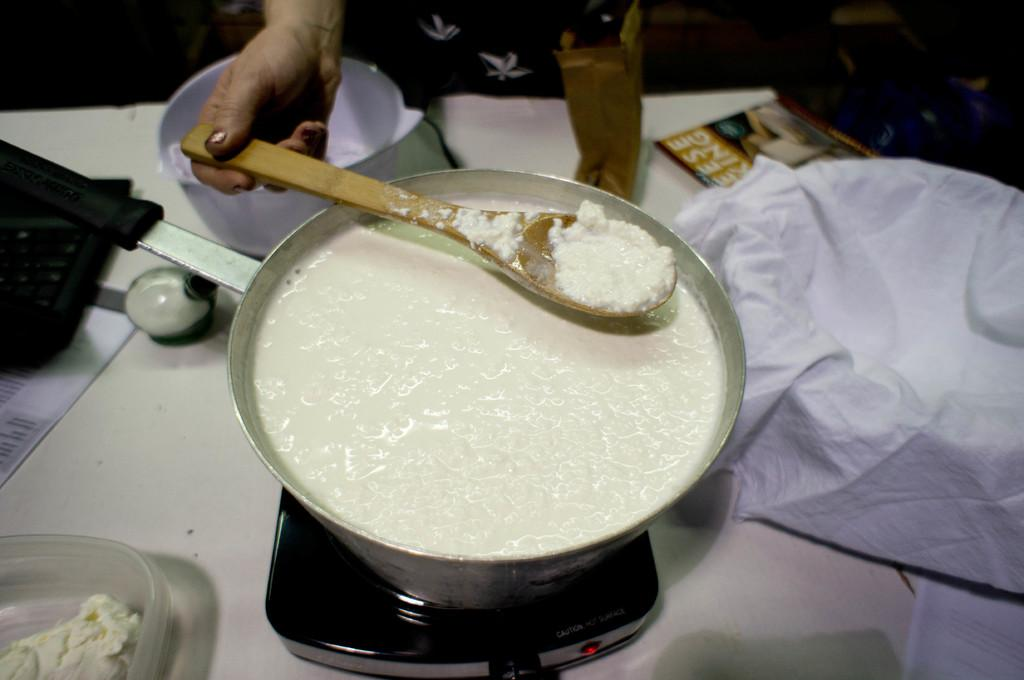<image>
Relay a brief, clear account of the picture shown. a person cooks something in a bowl near a magazine with letters EESE on it 